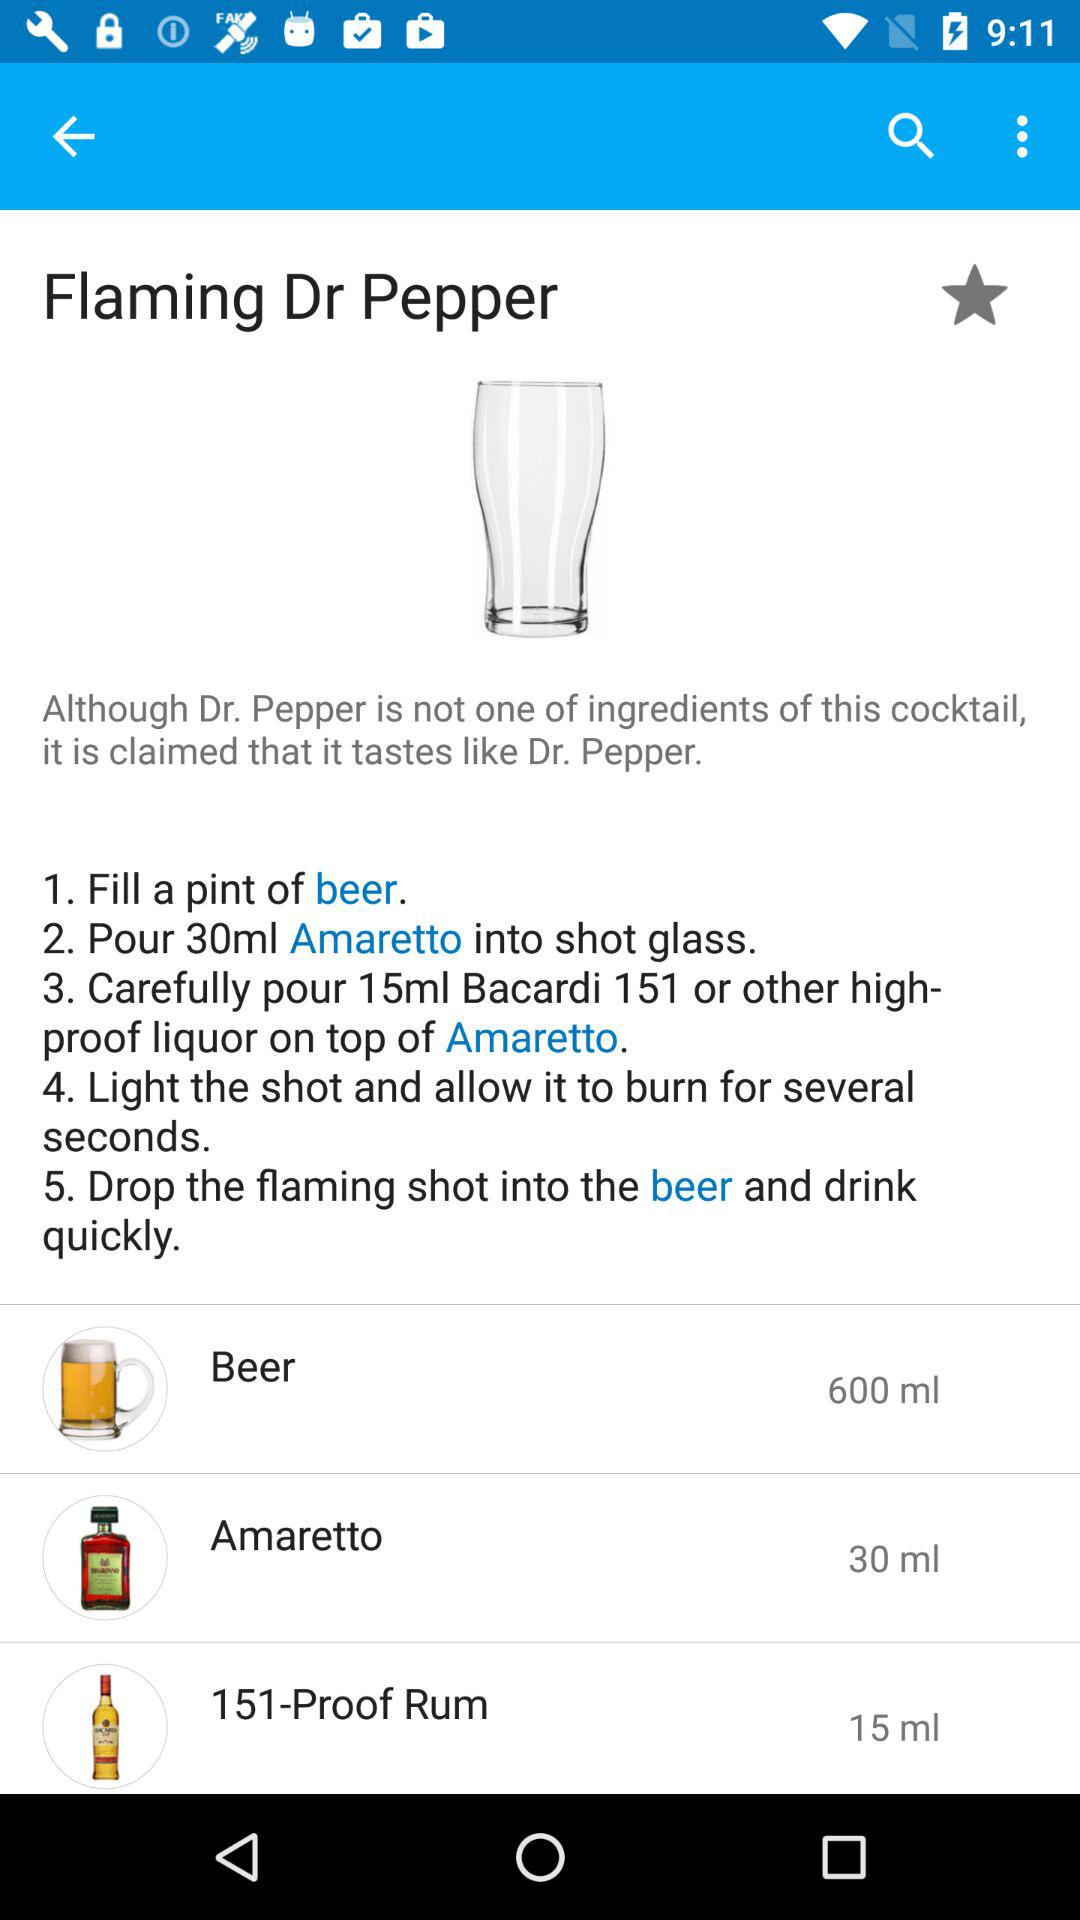How many ml of beer is poured in a pint?
When the provided information is insufficient, respond with <no answer>. <no answer> 